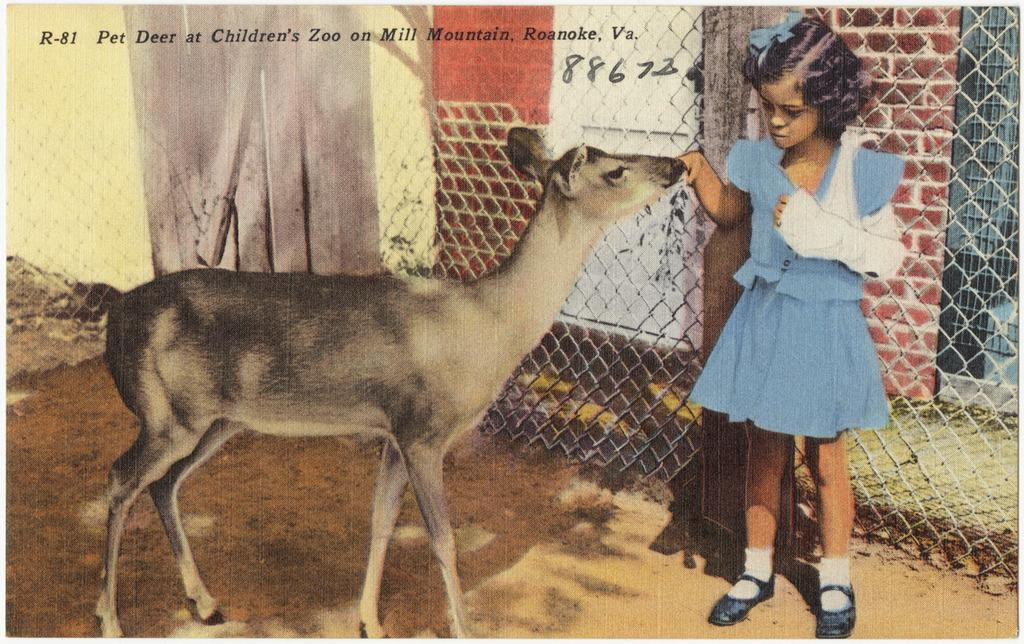Who is the main subject in the image? There is a girl in the image. What is the girl wearing? The girl is wearing a blue dress. What is the girl doing in the image? The girl is touching a goat. What can be seen in the background of the image? There is a fence and a yellow wall in the background of the image. What temper does the goat have in the image? The image does not provide information about the goat's temper. What chance does the girl have to pet the goat in the image? The image does not provide information about the likelihood of the girl petting the goat. 